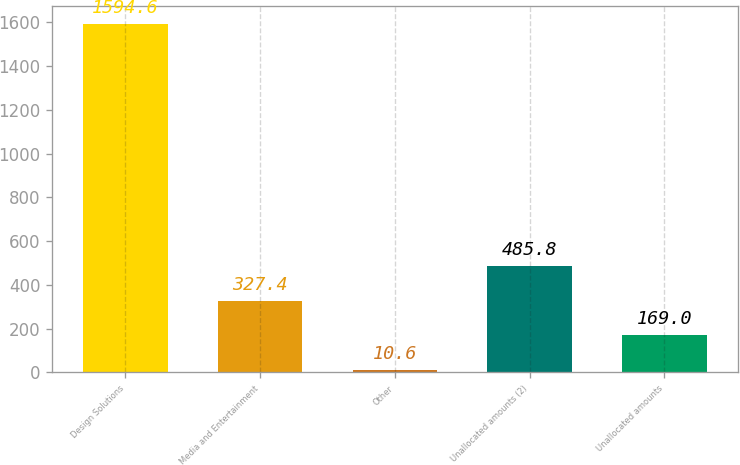<chart> <loc_0><loc_0><loc_500><loc_500><bar_chart><fcel>Design Solutions<fcel>Media and Entertainment<fcel>Other<fcel>Unallocated amounts (2)<fcel>Unallocated amounts<nl><fcel>1594.6<fcel>327.4<fcel>10.6<fcel>485.8<fcel>169<nl></chart> 